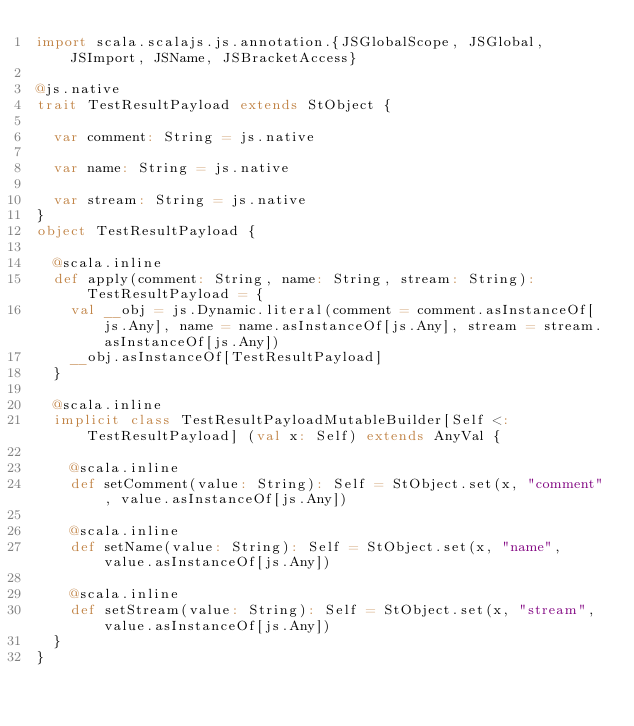<code> <loc_0><loc_0><loc_500><loc_500><_Scala_>import scala.scalajs.js.annotation.{JSGlobalScope, JSGlobal, JSImport, JSName, JSBracketAccess}

@js.native
trait TestResultPayload extends StObject {
  
  var comment: String = js.native
  
  var name: String = js.native
  
  var stream: String = js.native
}
object TestResultPayload {
  
  @scala.inline
  def apply(comment: String, name: String, stream: String): TestResultPayload = {
    val __obj = js.Dynamic.literal(comment = comment.asInstanceOf[js.Any], name = name.asInstanceOf[js.Any], stream = stream.asInstanceOf[js.Any])
    __obj.asInstanceOf[TestResultPayload]
  }
  
  @scala.inline
  implicit class TestResultPayloadMutableBuilder[Self <: TestResultPayload] (val x: Self) extends AnyVal {
    
    @scala.inline
    def setComment(value: String): Self = StObject.set(x, "comment", value.asInstanceOf[js.Any])
    
    @scala.inline
    def setName(value: String): Self = StObject.set(x, "name", value.asInstanceOf[js.Any])
    
    @scala.inline
    def setStream(value: String): Self = StObject.set(x, "stream", value.asInstanceOf[js.Any])
  }
}
</code> 